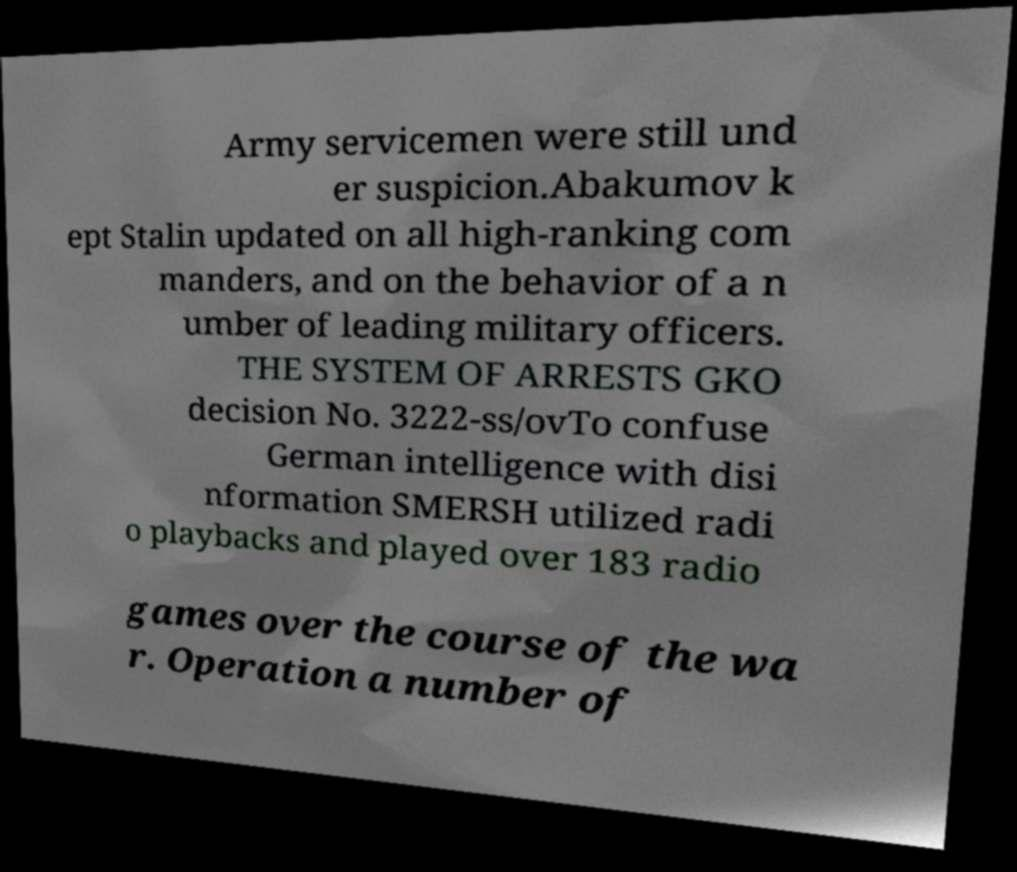For documentation purposes, I need the text within this image transcribed. Could you provide that? Army servicemen were still und er suspicion.Abakumov k ept Stalin updated on all high-ranking com manders, and on the behavior of a n umber of leading military officers. THE SYSTEM OF ARRESTS GKO decision No. 3222-ss/ovTo confuse German intelligence with disi nformation SMERSH utilized radi o playbacks and played over 183 radio games over the course of the wa r. Operation a number of 